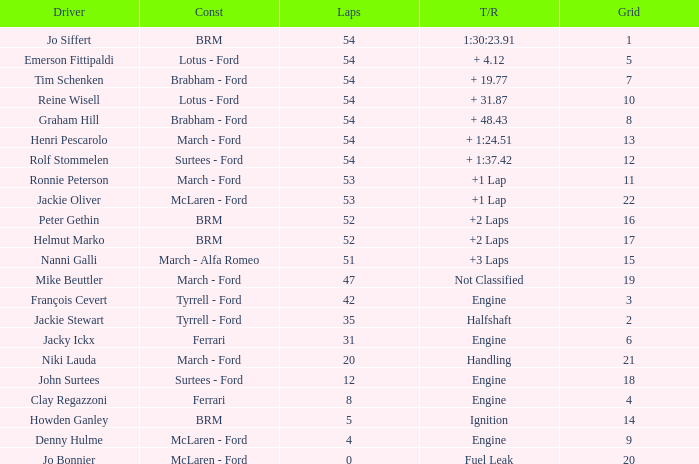What is the low grid that has brm and over 54 laps? None. 